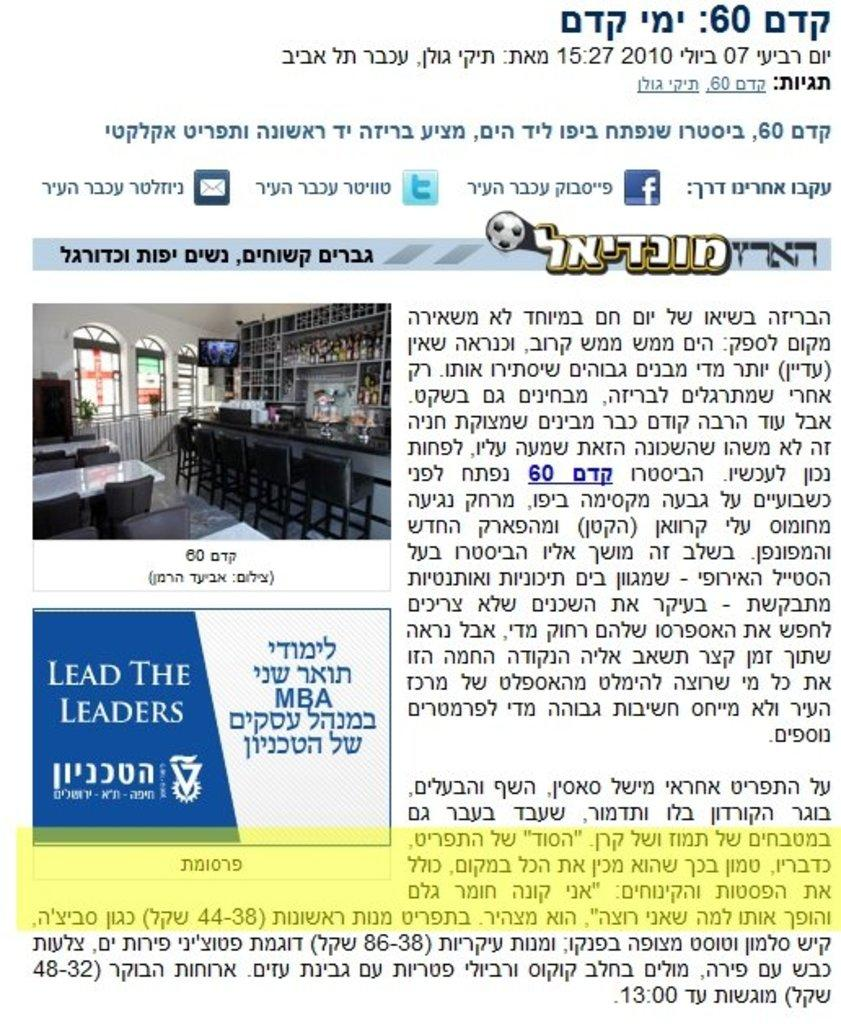<image>
Present a compact description of the photo's key features. An advertisement for an MBA program in Israel. 